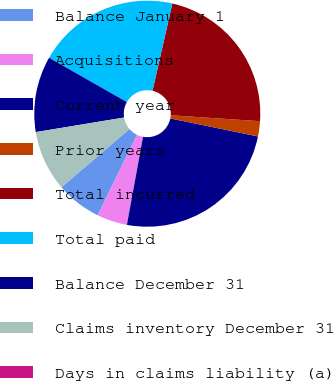Convert chart. <chart><loc_0><loc_0><loc_500><loc_500><pie_chart><fcel>Balance January 1<fcel>Acquisitions<fcel>Current year<fcel>Prior years<fcel>Total incurred<fcel>Total paid<fcel>Balance December 31<fcel>Claims inventory December 31<fcel>Days in claims liability (a)<nl><fcel>6.5%<fcel>4.34%<fcel>24.66%<fcel>2.17%<fcel>22.5%<fcel>20.33%<fcel>10.84%<fcel>8.67%<fcel>0.0%<nl></chart> 